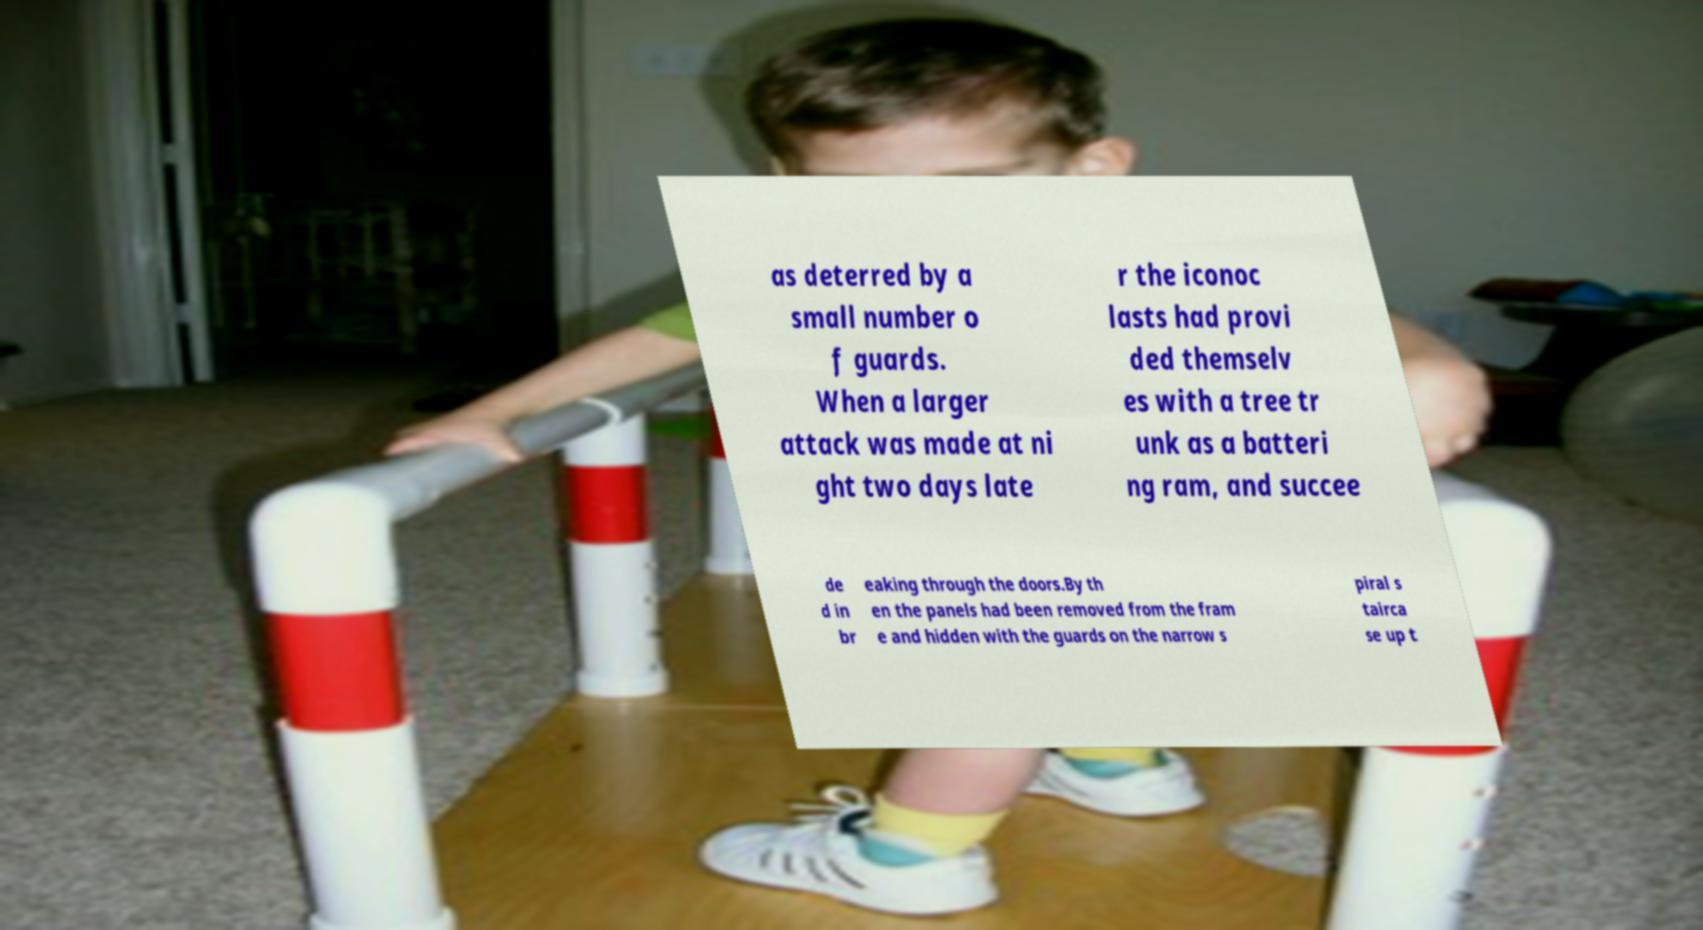Can you read and provide the text displayed in the image?This photo seems to have some interesting text. Can you extract and type it out for me? as deterred by a small number o f guards. When a larger attack was made at ni ght two days late r the iconoc lasts had provi ded themselv es with a tree tr unk as a batteri ng ram, and succee de d in br eaking through the doors.By th en the panels had been removed from the fram e and hidden with the guards on the narrow s piral s tairca se up t 